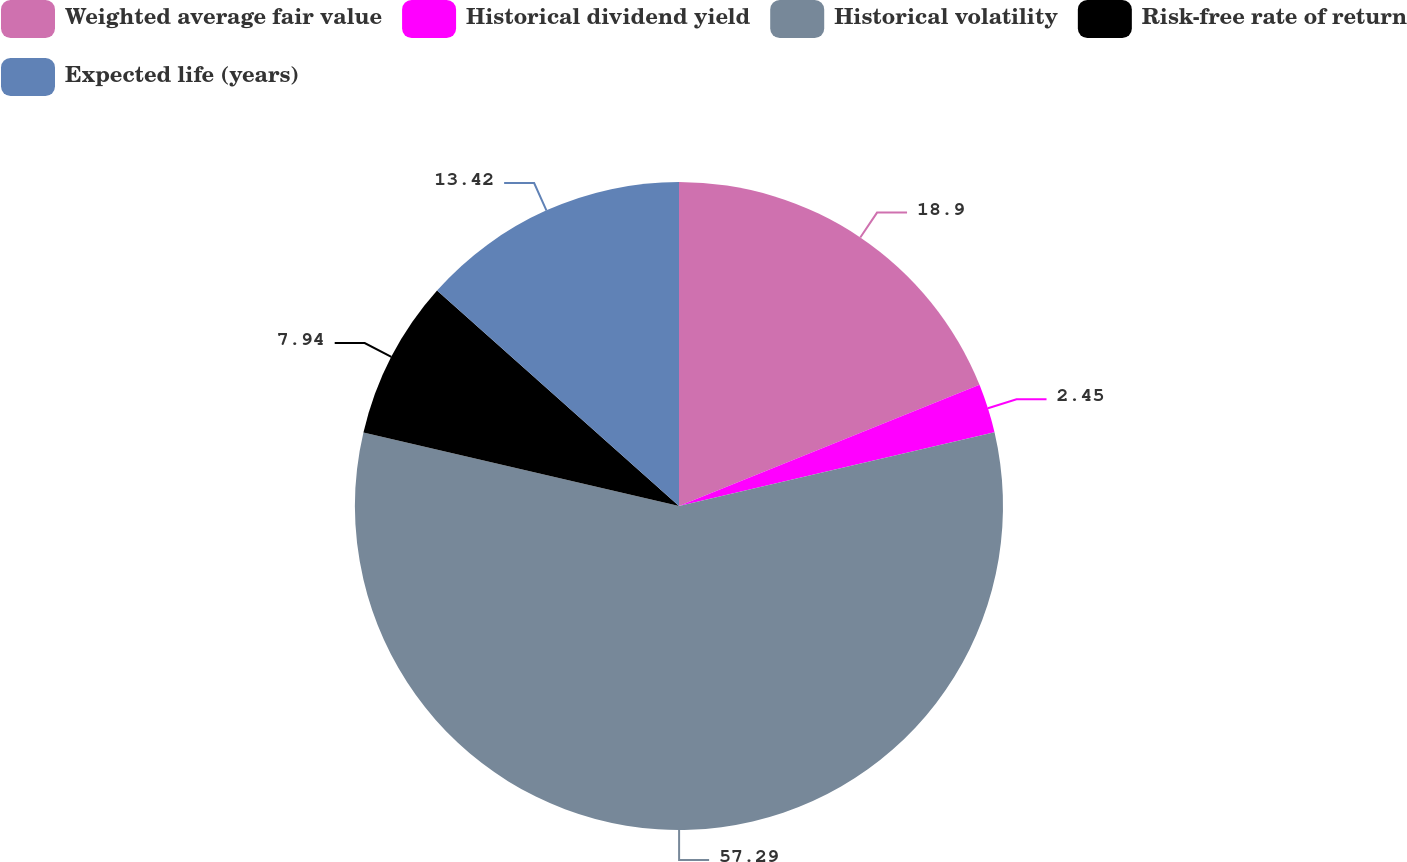Convert chart. <chart><loc_0><loc_0><loc_500><loc_500><pie_chart><fcel>Weighted average fair value<fcel>Historical dividend yield<fcel>Historical volatility<fcel>Risk-free rate of return<fcel>Expected life (years)<nl><fcel>18.9%<fcel>2.45%<fcel>57.29%<fcel>7.94%<fcel>13.42%<nl></chart> 